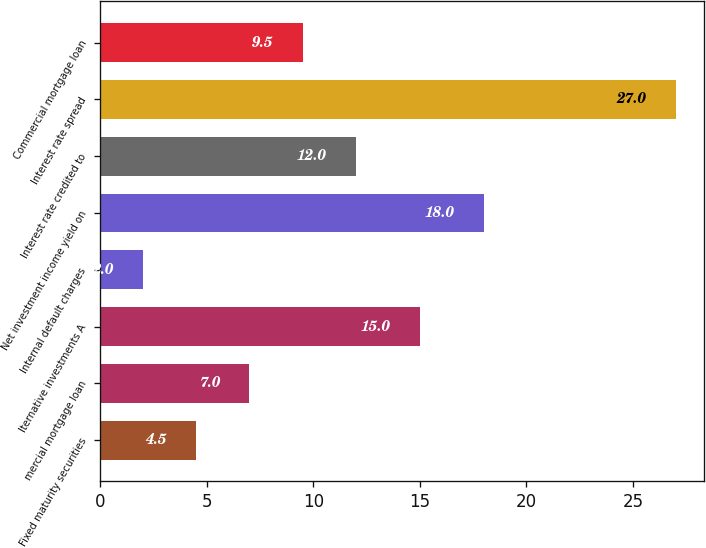Convert chart. <chart><loc_0><loc_0><loc_500><loc_500><bar_chart><fcel>Fixed maturity securities<fcel>mercial mortgage loan<fcel>lternative investments A<fcel>Internal default charges<fcel>Net investment income yield on<fcel>Interest rate credited to<fcel>Interest rate spread<fcel>Commercial mortgage loan<nl><fcel>4.5<fcel>7<fcel>15<fcel>2<fcel>18<fcel>12<fcel>27<fcel>9.5<nl></chart> 